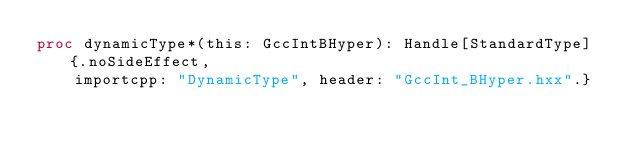Convert code to text. <code><loc_0><loc_0><loc_500><loc_500><_Nim_>proc dynamicType*(this: GccIntBHyper): Handle[StandardType] {.noSideEffect,
    importcpp: "DynamicType", header: "GccInt_BHyper.hxx".}

























</code> 